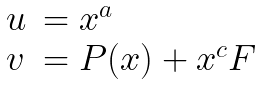Convert formula to latex. <formula><loc_0><loc_0><loc_500><loc_500>\begin{array} { l l } u & = x ^ { a } \\ v & = P ( x ) + x ^ { c } F \end{array}</formula> 